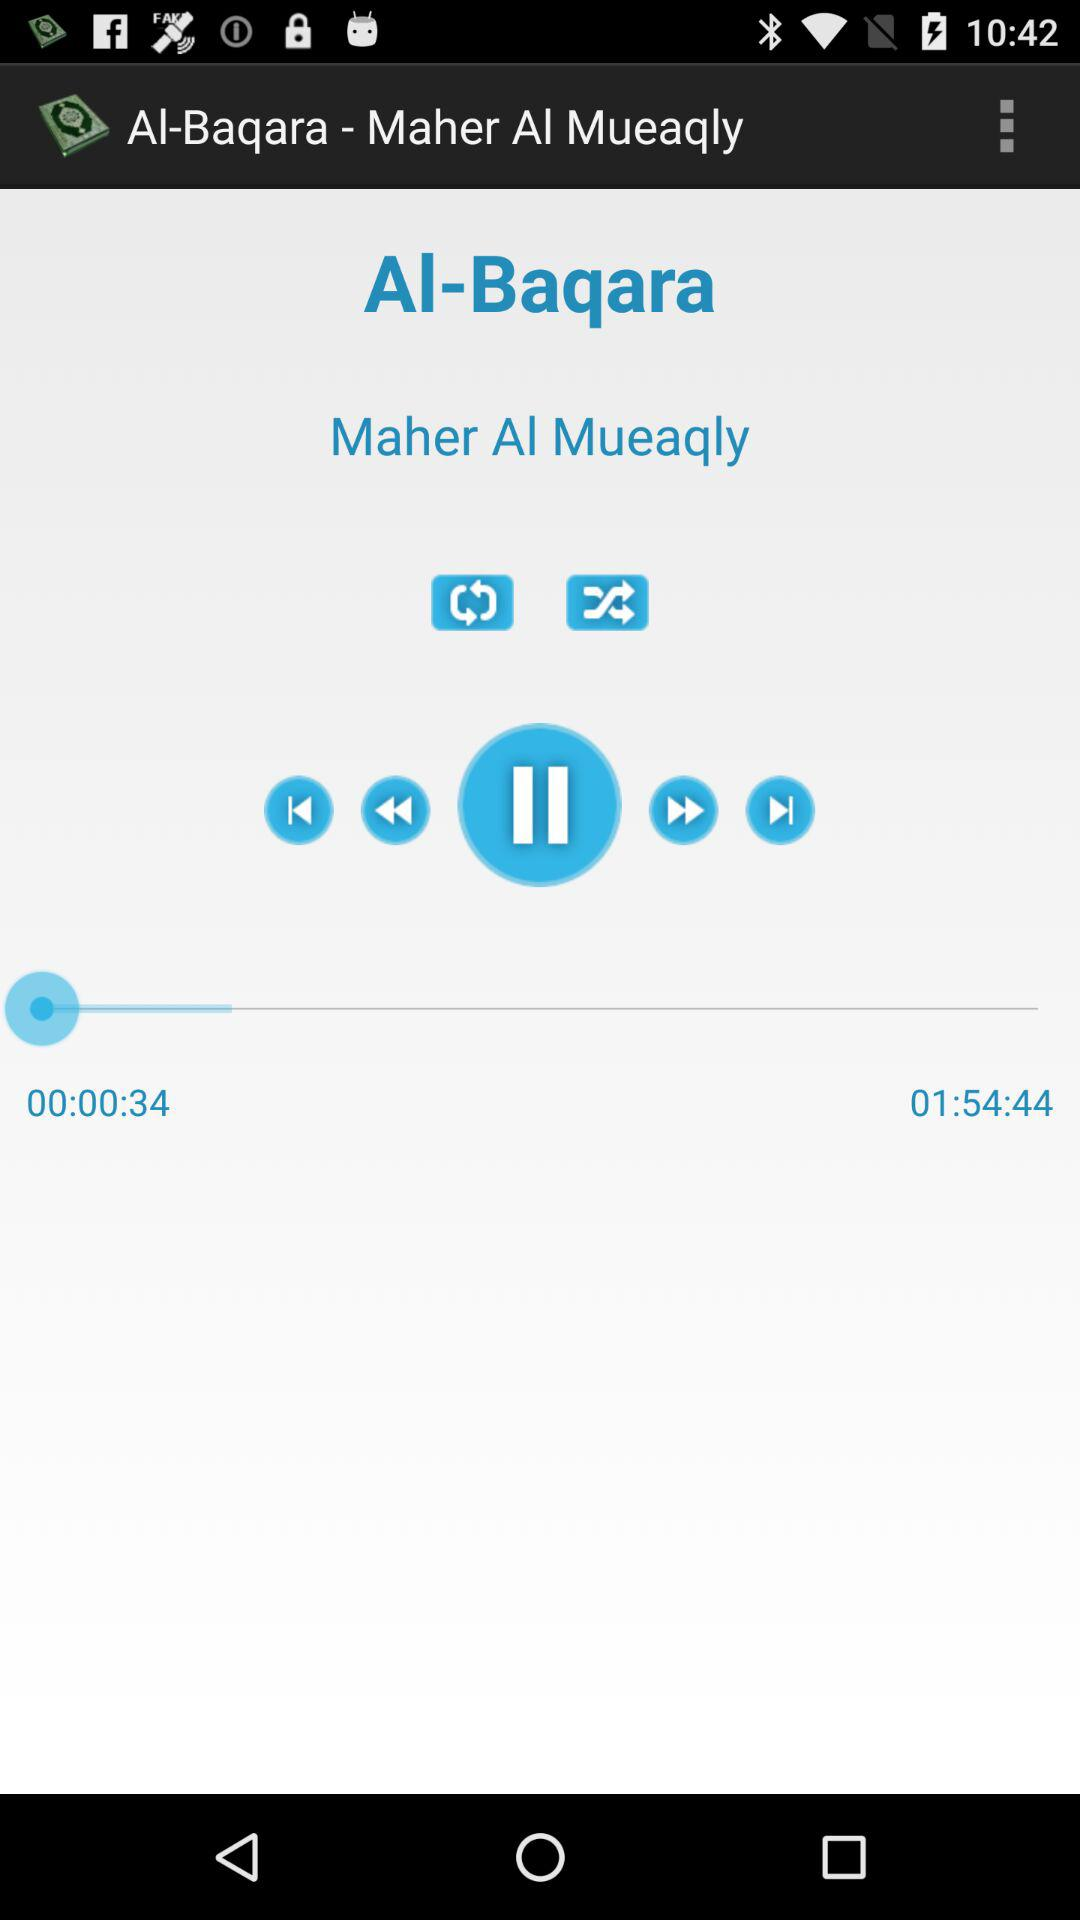How long is the current song?
Answer the question using a single word or phrase. 01:54:44 